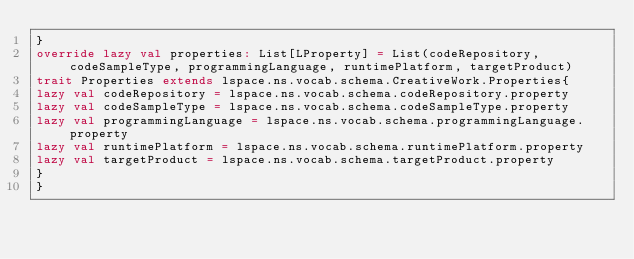Convert code to text. <code><loc_0><loc_0><loc_500><loc_500><_Scala_>}
override lazy val properties: List[LProperty] = List(codeRepository, codeSampleType, programmingLanguage, runtimePlatform, targetProduct)
trait Properties extends lspace.ns.vocab.schema.CreativeWork.Properties{
lazy val codeRepository = lspace.ns.vocab.schema.codeRepository.property
lazy val codeSampleType = lspace.ns.vocab.schema.codeSampleType.property
lazy val programmingLanguage = lspace.ns.vocab.schema.programmingLanguage.property
lazy val runtimePlatform = lspace.ns.vocab.schema.runtimePlatform.property
lazy val targetProduct = lspace.ns.vocab.schema.targetProduct.property
}
}</code> 